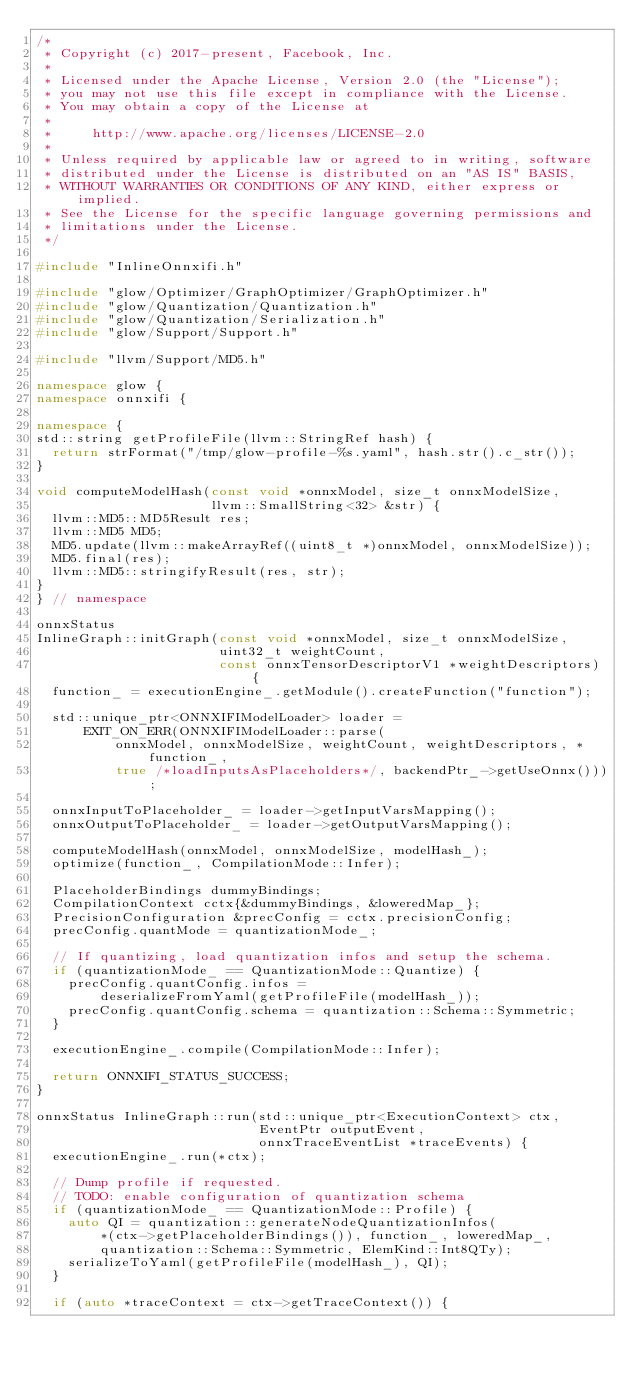Convert code to text. <code><loc_0><loc_0><loc_500><loc_500><_C++_>/*
 * Copyright (c) 2017-present, Facebook, Inc.
 *
 * Licensed under the Apache License, Version 2.0 (the "License");
 * you may not use this file except in compliance with the License.
 * You may obtain a copy of the License at
 *
 *     http://www.apache.org/licenses/LICENSE-2.0
 *
 * Unless required by applicable law or agreed to in writing, software
 * distributed under the License is distributed on an "AS IS" BASIS,
 * WITHOUT WARRANTIES OR CONDITIONS OF ANY KIND, either express or implied.
 * See the License for the specific language governing permissions and
 * limitations under the License.
 */

#include "InlineOnnxifi.h"

#include "glow/Optimizer/GraphOptimizer/GraphOptimizer.h"
#include "glow/Quantization/Quantization.h"
#include "glow/Quantization/Serialization.h"
#include "glow/Support/Support.h"

#include "llvm/Support/MD5.h"

namespace glow {
namespace onnxifi {

namespace {
std::string getProfileFile(llvm::StringRef hash) {
  return strFormat("/tmp/glow-profile-%s.yaml", hash.str().c_str());
}

void computeModelHash(const void *onnxModel, size_t onnxModelSize,
                      llvm::SmallString<32> &str) {
  llvm::MD5::MD5Result res;
  llvm::MD5 MD5;
  MD5.update(llvm::makeArrayRef((uint8_t *)onnxModel, onnxModelSize));
  MD5.final(res);
  llvm::MD5::stringifyResult(res, str);
}
} // namespace

onnxStatus
InlineGraph::initGraph(const void *onnxModel, size_t onnxModelSize,
                       uint32_t weightCount,
                       const onnxTensorDescriptorV1 *weightDescriptors) {
  function_ = executionEngine_.getModule().createFunction("function");

  std::unique_ptr<ONNXIFIModelLoader> loader =
      EXIT_ON_ERR(ONNXIFIModelLoader::parse(
          onnxModel, onnxModelSize, weightCount, weightDescriptors, *function_,
          true /*loadInputsAsPlaceholders*/, backendPtr_->getUseOnnx()));

  onnxInputToPlaceholder_ = loader->getInputVarsMapping();
  onnxOutputToPlaceholder_ = loader->getOutputVarsMapping();

  computeModelHash(onnxModel, onnxModelSize, modelHash_);
  optimize(function_, CompilationMode::Infer);

  PlaceholderBindings dummyBindings;
  CompilationContext cctx{&dummyBindings, &loweredMap_};
  PrecisionConfiguration &precConfig = cctx.precisionConfig;
  precConfig.quantMode = quantizationMode_;

  // If quantizing, load quantization infos and setup the schema.
  if (quantizationMode_ == QuantizationMode::Quantize) {
    precConfig.quantConfig.infos =
        deserializeFromYaml(getProfileFile(modelHash_));
    precConfig.quantConfig.schema = quantization::Schema::Symmetric;
  }

  executionEngine_.compile(CompilationMode::Infer);

  return ONNXIFI_STATUS_SUCCESS;
}

onnxStatus InlineGraph::run(std::unique_ptr<ExecutionContext> ctx,
                            EventPtr outputEvent,
                            onnxTraceEventList *traceEvents) {
  executionEngine_.run(*ctx);

  // Dump profile if requested.
  // TODO: enable configuration of quantization schema
  if (quantizationMode_ == QuantizationMode::Profile) {
    auto QI = quantization::generateNodeQuantizationInfos(
        *(ctx->getPlaceholderBindings()), function_, loweredMap_,
        quantization::Schema::Symmetric, ElemKind::Int8QTy);
    serializeToYaml(getProfileFile(modelHash_), QI);
  }

  if (auto *traceContext = ctx->getTraceContext()) {</code> 